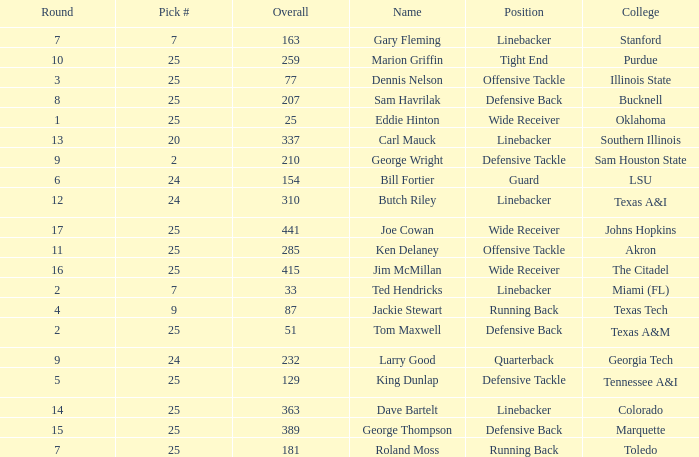Round larger than 6, and a Pick # smaller than 25, and a College of southern Illinois has what position? Linebacker. 